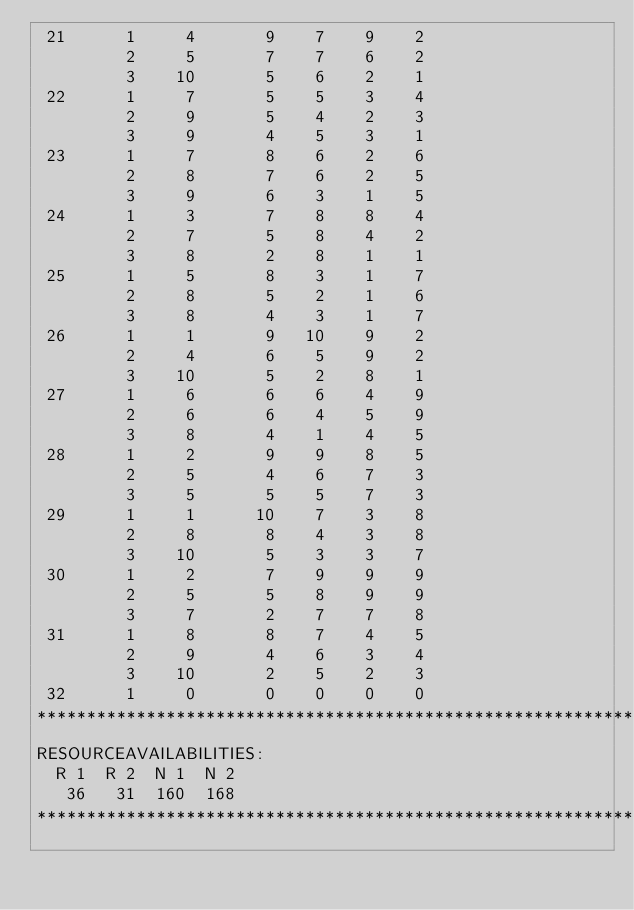<code> <loc_0><loc_0><loc_500><loc_500><_ObjectiveC_> 21      1     4       9    7    9    2
         2     5       7    7    6    2
         3    10       5    6    2    1
 22      1     7       5    5    3    4
         2     9       5    4    2    3
         3     9       4    5    3    1
 23      1     7       8    6    2    6
         2     8       7    6    2    5
         3     9       6    3    1    5
 24      1     3       7    8    8    4
         2     7       5    8    4    2
         3     8       2    8    1    1
 25      1     5       8    3    1    7
         2     8       5    2    1    6
         3     8       4    3    1    7
 26      1     1       9   10    9    2
         2     4       6    5    9    2
         3    10       5    2    8    1
 27      1     6       6    6    4    9
         2     6       6    4    5    9
         3     8       4    1    4    5
 28      1     2       9    9    8    5
         2     5       4    6    7    3
         3     5       5    5    7    3
 29      1     1      10    7    3    8
         2     8       8    4    3    8
         3    10       5    3    3    7
 30      1     2       7    9    9    9
         2     5       5    8    9    9
         3     7       2    7    7    8
 31      1     8       8    7    4    5
         2     9       4    6    3    4
         3    10       2    5    2    3
 32      1     0       0    0    0    0
************************************************************************
RESOURCEAVAILABILITIES:
  R 1  R 2  N 1  N 2
   36   31  160  168
************************************************************************
</code> 